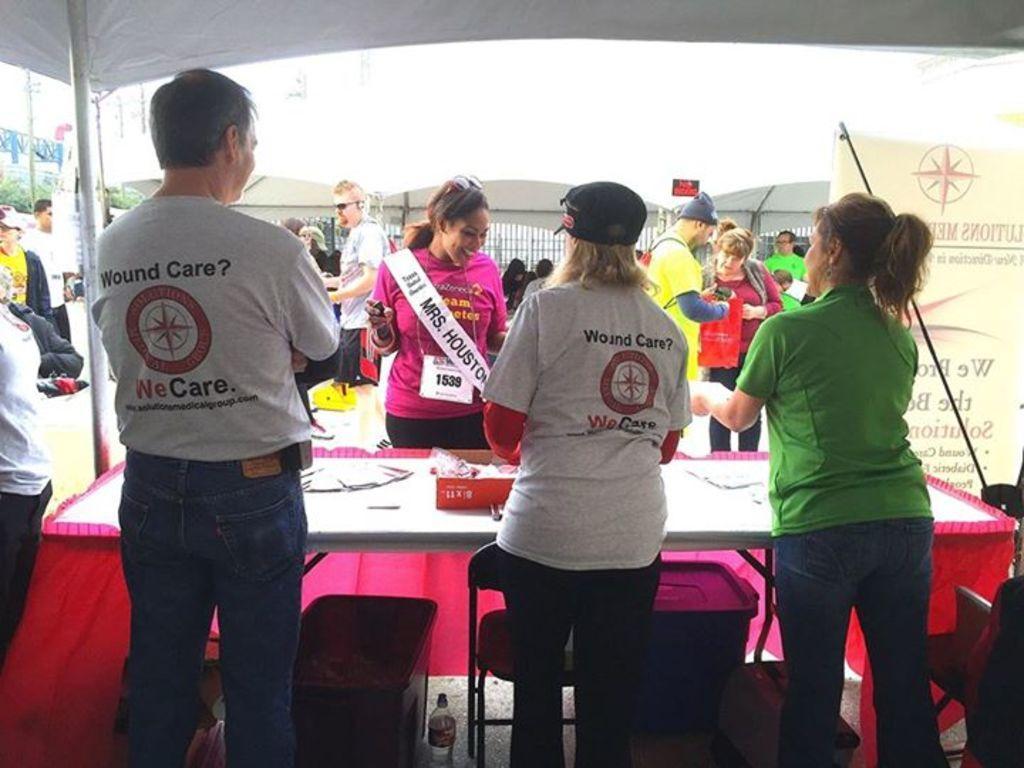Could you give a brief overview of what you see in this image? In this picture we can see some people are standing, there are chairs and a table in the front, on the right side there is a banner, in the background there are trees, at the bottom we can see a bottle and a dustbin, there is a tent at the top of the picture. 